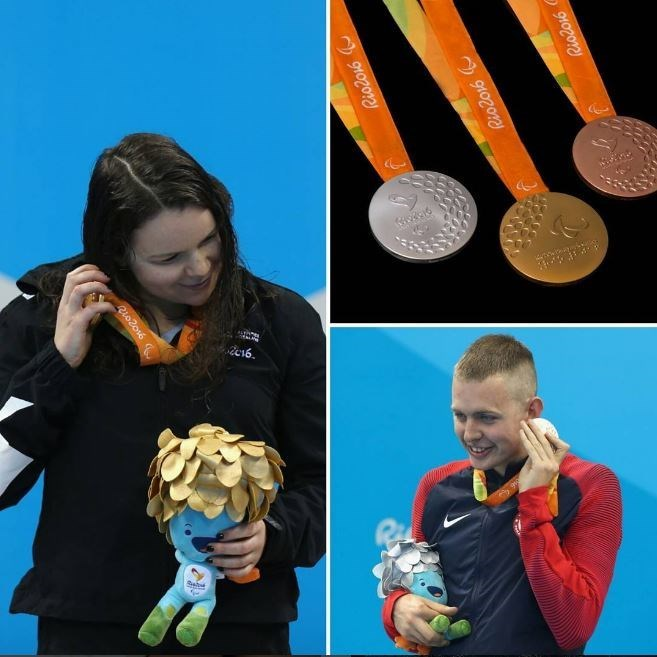Imagine a futuristic Olympic event where robots can also compete alongside humans. Describe one such event. In the not-so-distant future, the Olympics have evolved to include robotic athletes competing alongside humans. One such futuristic event is the 'Cyborg Relay'. In this event, teams composed of human and robotic swimmers work together in perfect harmony. The robots, equipped with advanced AI and human-like movement algorithms, complement the strategies and stamina of their human teammates. The relay involves a series of intricate maneuvers and seamless transitions between human swimmers and their robotic counterparts. This unique blend of technology and human skill makes for a thrilling spectacle, showcasing the symbiosis between humans and machines in the pursuit of excellence. The event symbolizes progress and the potential for collaboration between humans and advanced technologies, highlighting that the essence of competition and unity remains unchanged, even as the world steps into a new era. 